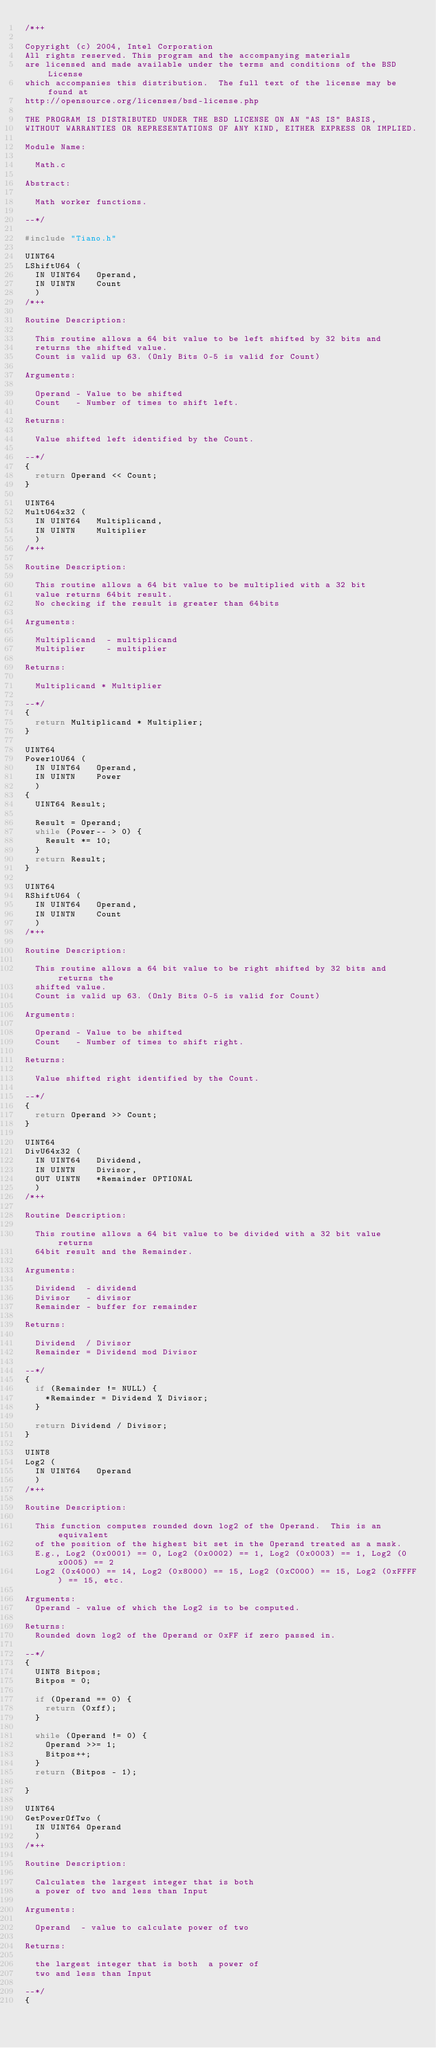Convert code to text. <code><loc_0><loc_0><loc_500><loc_500><_C_>/*++

Copyright (c) 2004, Intel Corporation                                                         
All rights reserved. This program and the accompanying materials                          
are licensed and made available under the terms and conditions of the BSD License         
which accompanies this distribution.  The full text of the license may be found at        
http://opensource.org/licenses/bsd-license.php                                            
                                                                                          
THE PROGRAM IS DISTRIBUTED UNDER THE BSD LICENSE ON AN "AS IS" BASIS,                     
WITHOUT WARRANTIES OR REPRESENTATIONS OF ANY KIND, EITHER EXPRESS OR IMPLIED.             

Module Name:

  Math.c

Abstract:

  Math worker functions. 

--*/

#include "Tiano.h"

UINT64
LShiftU64 (
  IN UINT64   Operand,
  IN UINTN    Count
  )
/*++

Routine Description:

  This routine allows a 64 bit value to be left shifted by 32 bits and 
  returns the shifted value.
  Count is valid up 63. (Only Bits 0-5 is valid for Count)

Arguments:

  Operand - Value to be shifted
  Count   - Number of times to shift left.
 
Returns:

  Value shifted left identified by the Count.

--*/
{
  return Operand << Count;
}

UINT64
MultU64x32 (
  IN UINT64   Multiplicand,
  IN UINTN    Multiplier
  )
/*++  
  
Routine Description:

  This routine allows a 64 bit value to be multiplied with a 32 bit 
  value returns 64bit result.
  No checking if the result is greater than 64bits

Arguments:

  Multiplicand  - multiplicand
  Multiplier    - multiplier

Returns:

  Multiplicand * Multiplier
  
--*/
{
  return Multiplicand * Multiplier;
}

UINT64
Power10U64 (
  IN UINT64   Operand,
  IN UINTN    Power
  )
{
  UINT64 Result;

  Result = Operand;
  while (Power-- > 0) {
    Result *= 10;
  }
  return Result;
}

UINT64
RShiftU64 (
  IN UINT64   Operand,
  IN UINTN    Count
  )
/*++

Routine Description:

  This routine allows a 64 bit value to be right shifted by 32 bits and returns the 
  shifted value.
  Count is valid up 63. (Only Bits 0-5 is valid for Count)

Arguments:

  Operand - Value to be shifted
  Count   - Number of times to shift right.
 
Returns:

  Value shifted right identified by the Count.

--*/
{
  return Operand >> Count;
}

UINT64
DivU64x32 (
  IN UINT64   Dividend,
  IN UINTN    Divisor,
  OUT UINTN   *Remainder OPTIONAL
  )
/*++

Routine Description:

  This routine allows a 64 bit value to be divided with a 32 bit value returns 
  64bit result and the Remainder.

Arguments:

  Dividend  - dividend
  Divisor   - divisor
  Remainder - buffer for remainder
 
Returns:

  Dividend  / Divisor
  Remainder = Dividend mod Divisor

--*/
{
  if (Remainder != NULL) {
    *Remainder = Dividend % Divisor;
  }

  return Dividend / Divisor;
}

UINT8
Log2 (
  IN UINT64   Operand
  )
/*++

Routine Description:

  This function computes rounded down log2 of the Operand.  This is an equivalent
  of the position of the highest bit set in the Operand treated as a mask.
  E.g., Log2 (0x0001) == 0, Log2 (0x0002) == 1, Log2 (0x0003) == 1, Log2 (0x0005) == 2
  Log2 (0x4000) == 14, Log2 (0x8000) == 15, Log2 (0xC000) == 15, Log2 (0xFFFF) == 15, etc.

Arguments:
  Operand - value of which the Log2 is to be computed.

Returns:
  Rounded down log2 of the Operand or 0xFF if zero passed in.

--*/
{
  UINT8 Bitpos;
  Bitpos = 0;

  if (Operand == 0) {
    return (0xff);
  }

  while (Operand != 0) {
    Operand >>= 1;
    Bitpos++;
  }
  return (Bitpos - 1);

}

UINT64
GetPowerOfTwo (
  IN UINT64 Operand
  )
/*++

Routine Description:

  Calculates the largest integer that is both 
  a power of two and less than Input

Arguments:

  Operand  - value to calculate power of two

Returns:

  the largest integer that is both  a power of 
  two and less than Input

--*/
{</code> 